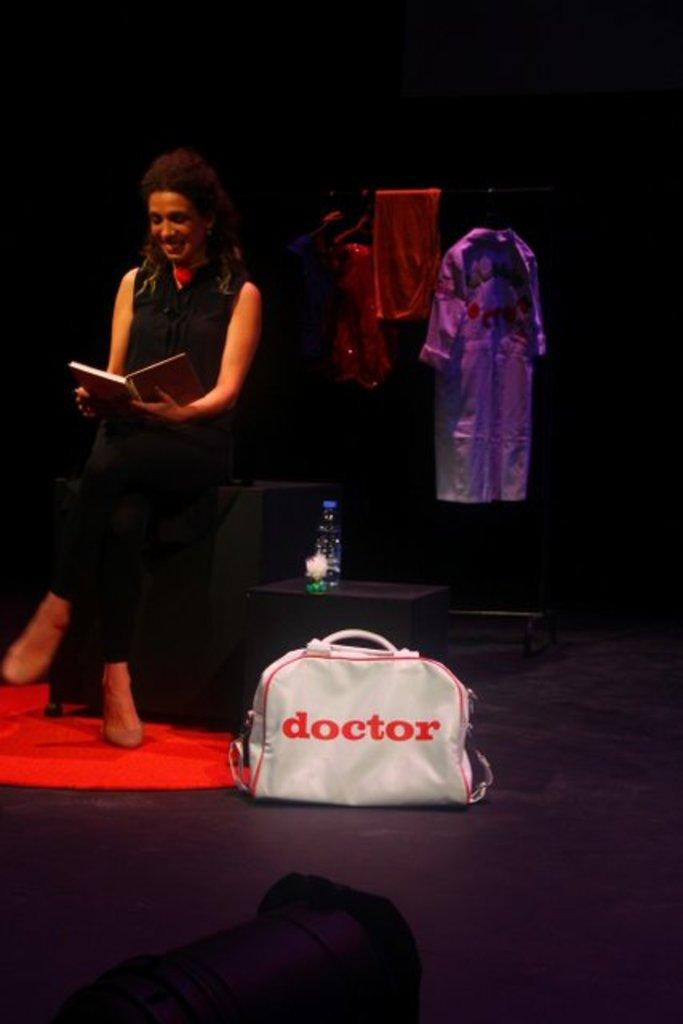Who is the main subject in the image? There is a woman in the image. What is the woman doing in the image? The woman is sitting on a stool and reading a book. What is the woman wearing in the image? The woman is wearing a black dress. What other object can be seen in the image? There is a doctor's bag in the image. What type of structure is the woman serving in the image? There is no indication in the image that the woman is serving in any structure. 